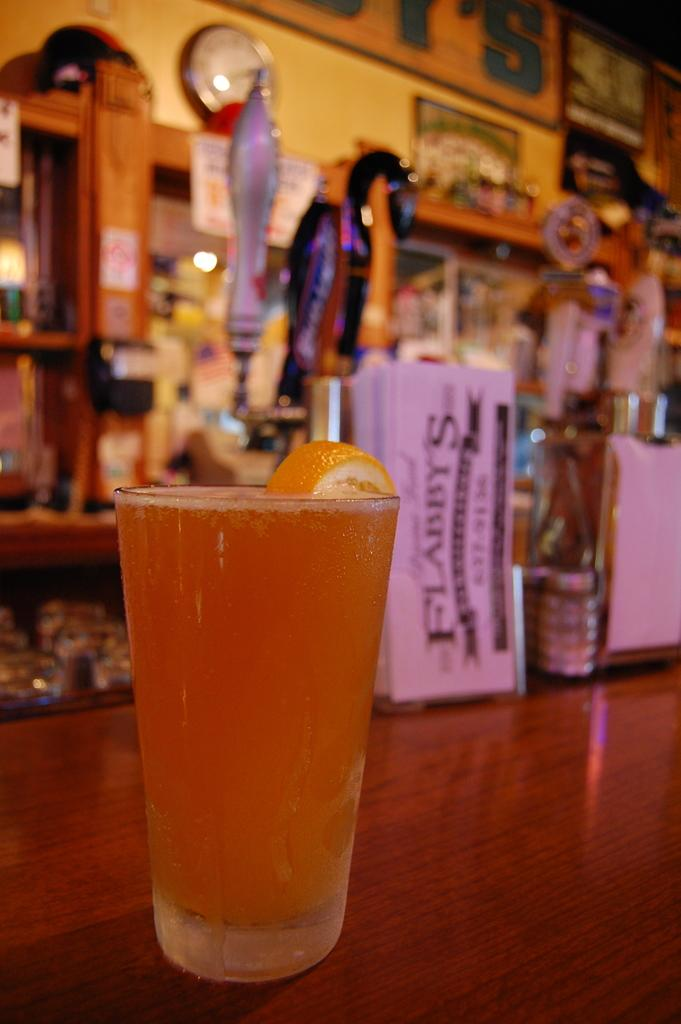<image>
Share a concise interpretation of the image provided. A beer on the bartop at Flabby's bar. 